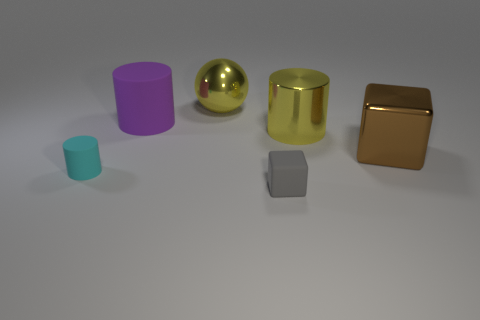Is there a metallic thing of the same color as the large shiny cylinder?
Give a very brief answer. Yes. What number of big metal balls have the same color as the shiny cylinder?
Keep it short and to the point. 1. There is a tiny gray object that is made of the same material as the purple thing; what is its shape?
Keep it short and to the point. Cube. Are there any other things of the same color as the metallic ball?
Your response must be concise. Yes. The big cylinder that is on the right side of the large shiny object left of the big yellow cylinder is made of what material?
Give a very brief answer. Metal. Is there a yellow metallic thing that has the same shape as the tiny cyan object?
Offer a terse response. Yes. How many other things are there of the same shape as the tiny gray object?
Offer a terse response. 1. What shape is the thing that is in front of the shiny cylinder and behind the cyan matte object?
Provide a succinct answer. Cube. There is a rubber object to the right of the sphere; how big is it?
Provide a short and direct response. Small. Do the cyan rubber cylinder and the gray rubber cube have the same size?
Ensure brevity in your answer.  Yes. 